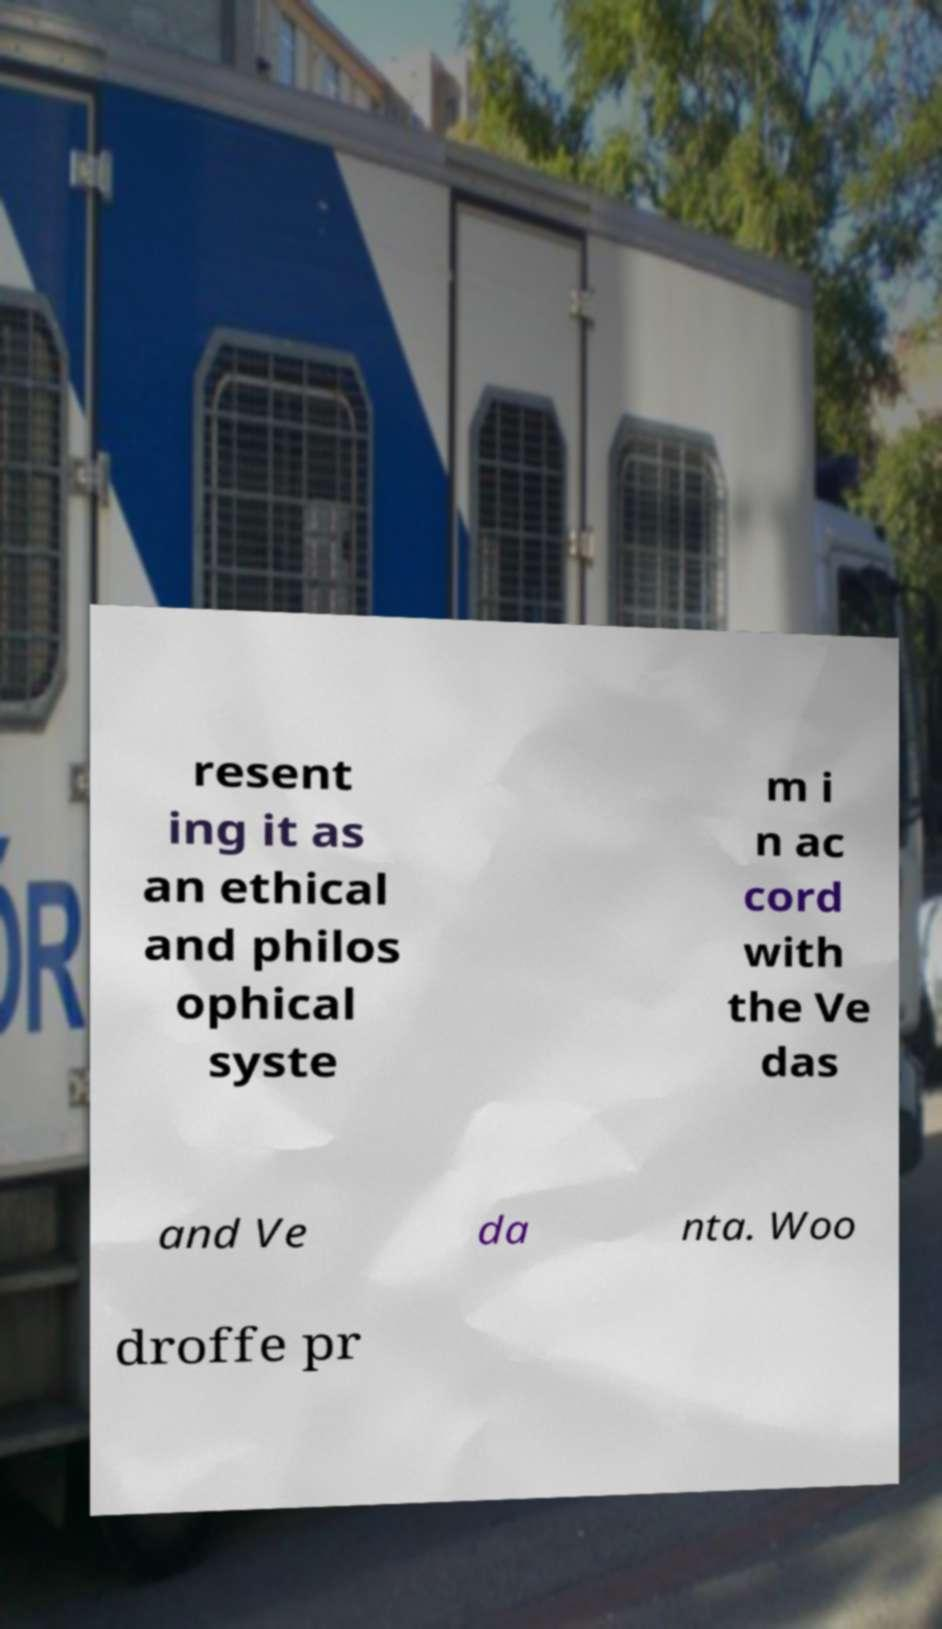There's text embedded in this image that I need extracted. Can you transcribe it verbatim? resent ing it as an ethical and philos ophical syste m i n ac cord with the Ve das and Ve da nta. Woo droffe pr 